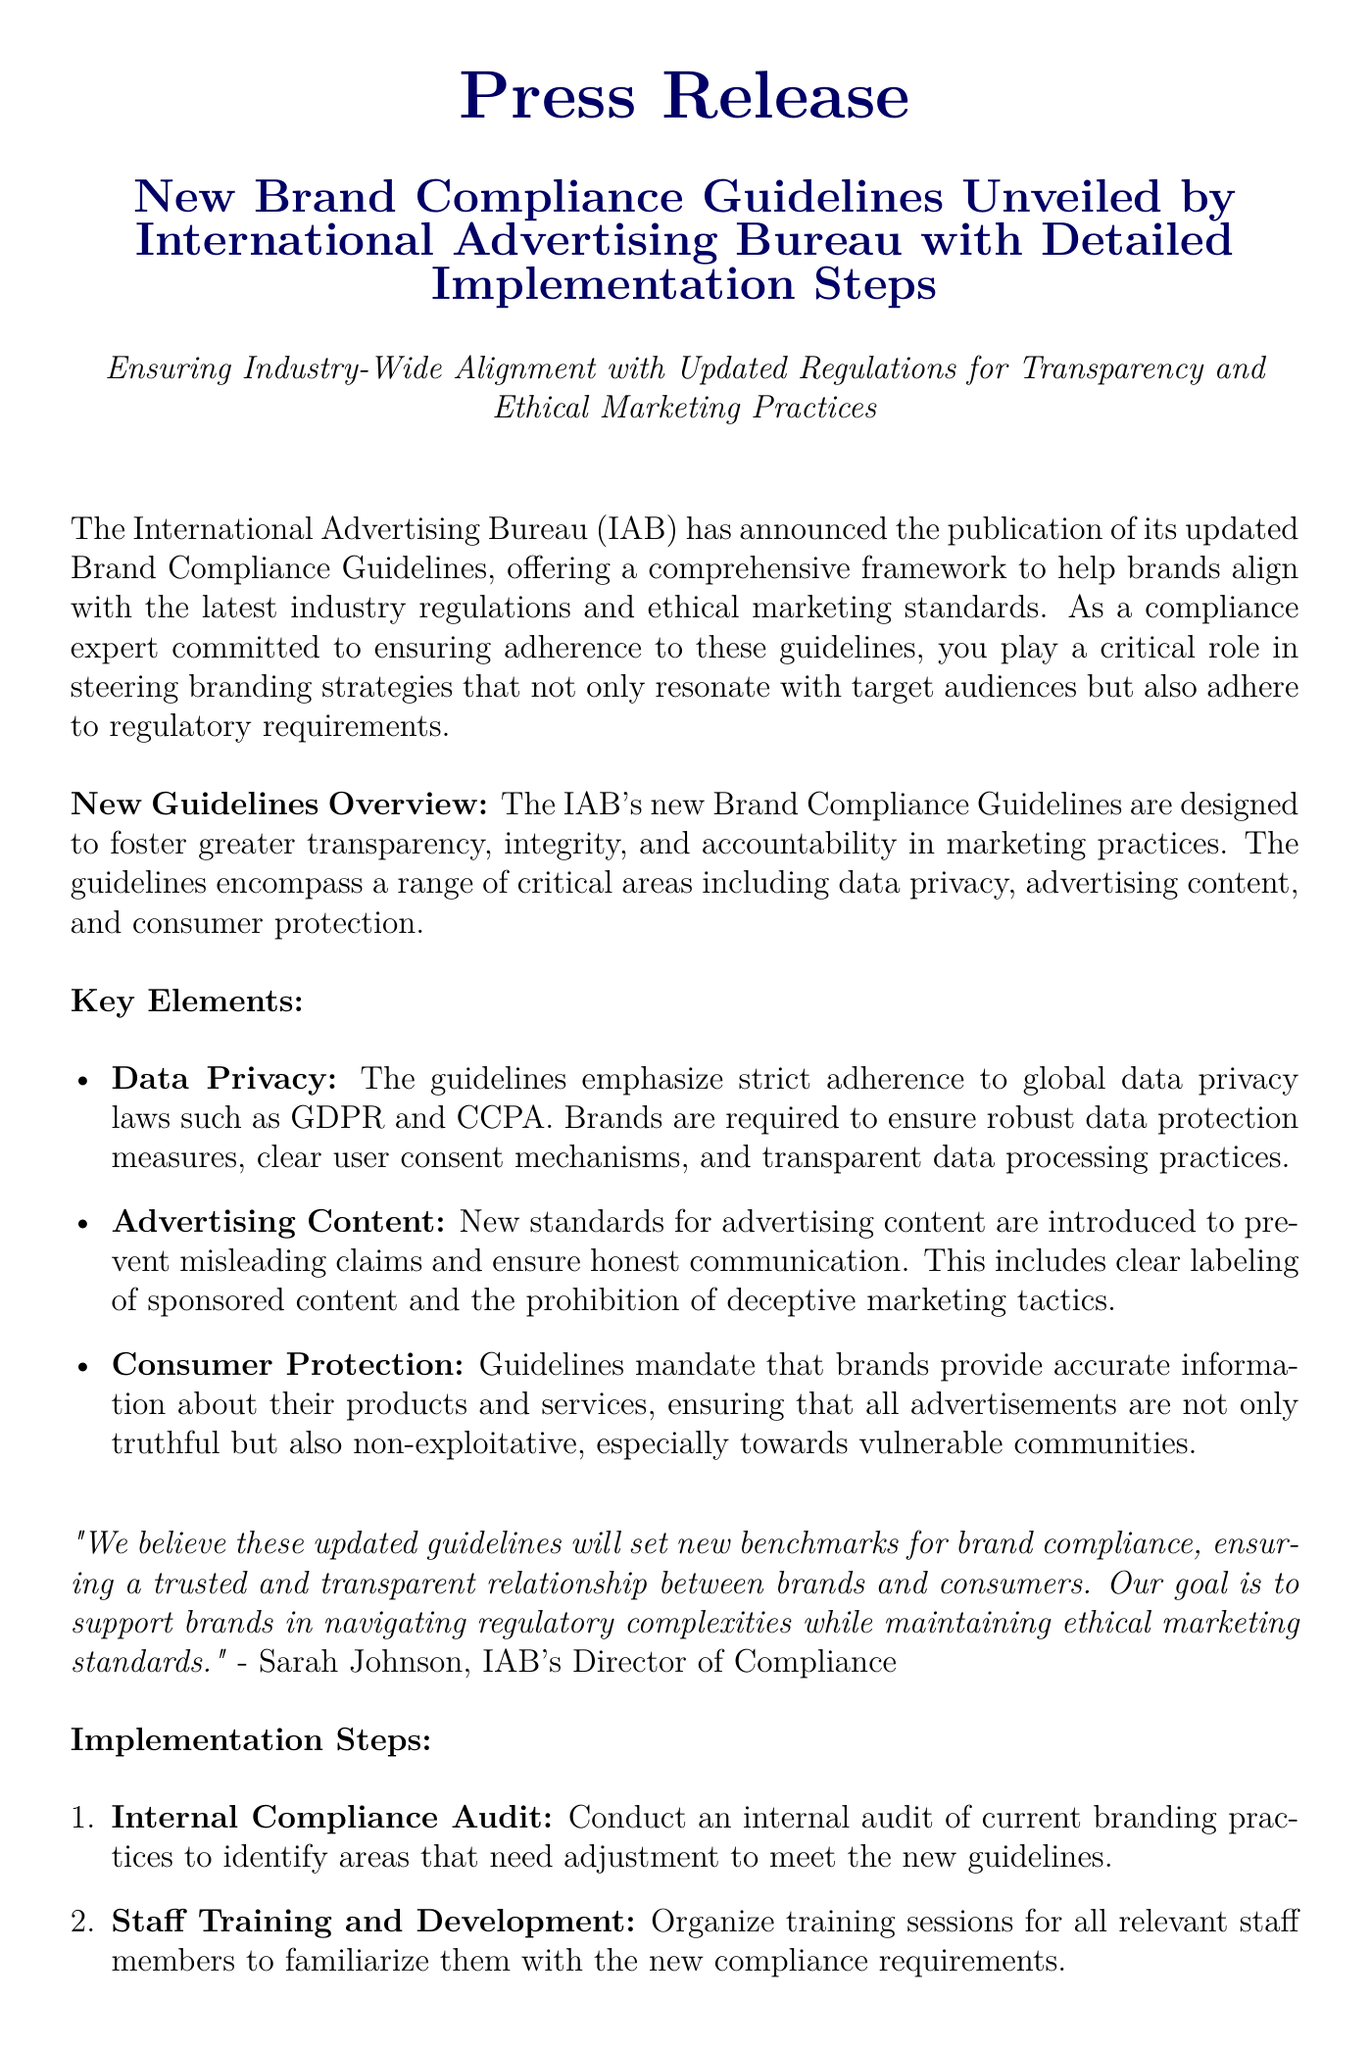What organization published the new guidelines? The document states that the International Advertising Bureau published the new guidelines.
Answer: International Advertising Bureau What do the new guidelines aim to ensure? The guidelines aim to ensure transparency and ethical marketing practices.
Answer: Transparency and ethical marketing practices Which data privacy laws are emphasized in the guidelines? The document mentions GDPR and CCPA as the data privacy laws emphasized in the guidelines.
Answer: GDPR and CCPA How many key elements are outlined in the guidelines? The document lists three key elements under the guidelines.
Answer: Three What is the first implementation step suggested? The first implementation step outlined in the document is conducting an internal compliance audit.
Answer: Internal compliance audit Who is quoted in the press release? The press release includes a quote from Sarah Johnson, IAB's Director of Compliance.
Answer: Sarah Johnson What is the purpose of the new guidelines according to Sarah Johnson? According to Sarah Johnson, the purpose is to set new benchmarks for brand compliance.
Answer: Set new benchmarks for brand compliance What aspect of marketing do the guidelines primarily address? The guidelines primarily address brand compliance within marketing practices.
Answer: Brand compliance What is the contact email provided in the document? The contact email given in the document is for Jane Doe, Public Relations Manager.
Answer: jane.doe@compliancefirm.com 